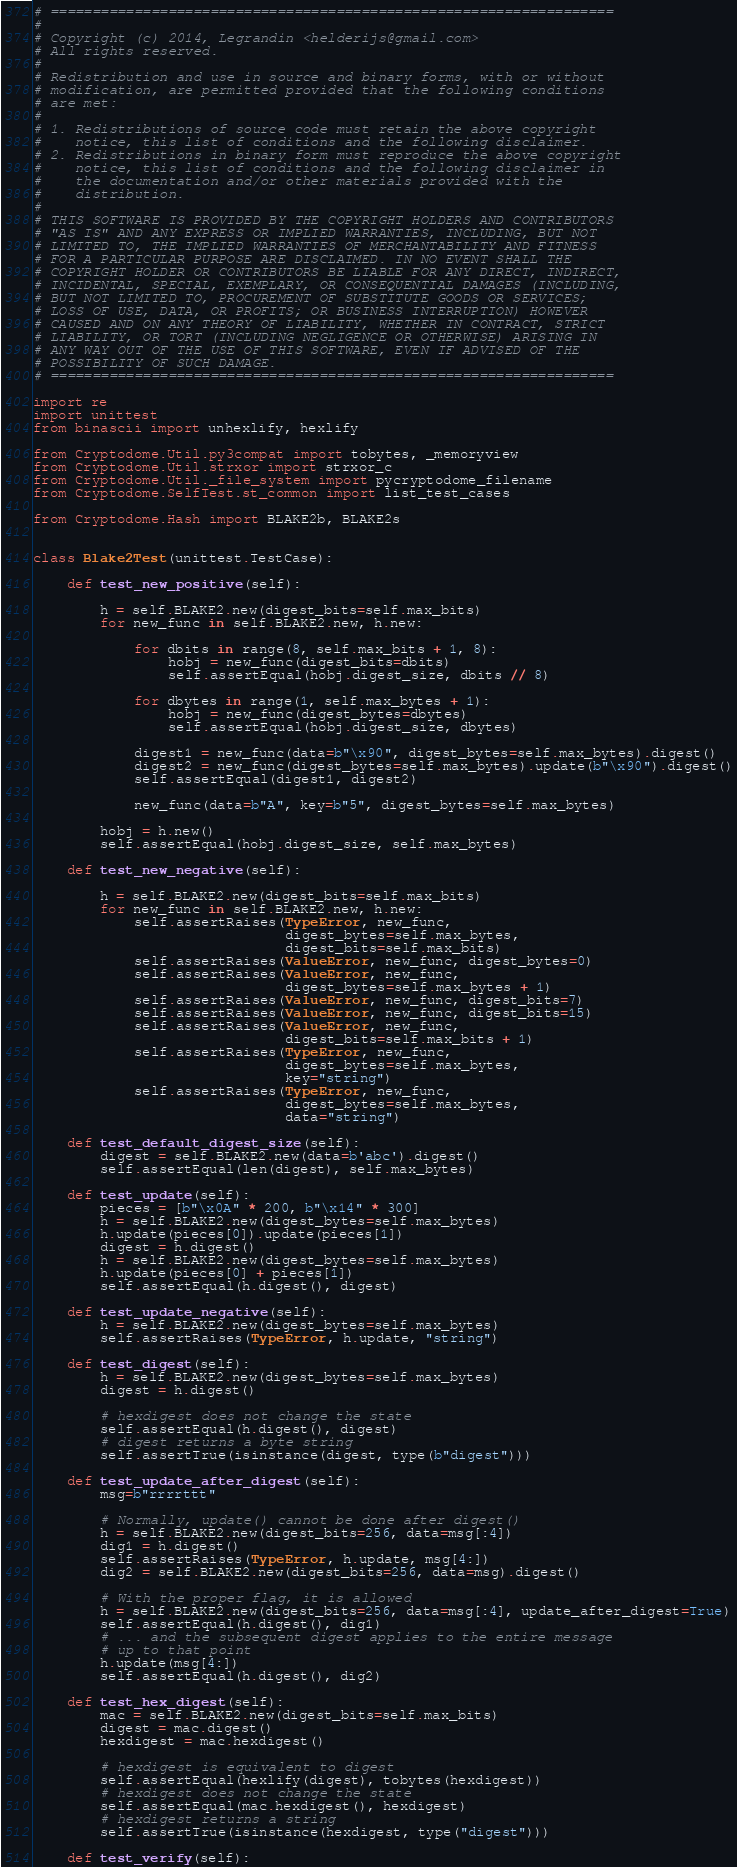Convert code to text. <code><loc_0><loc_0><loc_500><loc_500><_Python_># ===================================================================
#
# Copyright (c) 2014, Legrandin <helderijs@gmail.com>
# All rights reserved.
#
# Redistribution and use in source and binary forms, with or without
# modification, are permitted provided that the following conditions
# are met:
#
# 1. Redistributions of source code must retain the above copyright
#    notice, this list of conditions and the following disclaimer.
# 2. Redistributions in binary form must reproduce the above copyright
#    notice, this list of conditions and the following disclaimer in
#    the documentation and/or other materials provided with the
#    distribution.
#
# THIS SOFTWARE IS PROVIDED BY THE COPYRIGHT HOLDERS AND CONTRIBUTORS
# "AS IS" AND ANY EXPRESS OR IMPLIED WARRANTIES, INCLUDING, BUT NOT
# LIMITED TO, THE IMPLIED WARRANTIES OF MERCHANTABILITY AND FITNESS
# FOR A PARTICULAR PURPOSE ARE DISCLAIMED. IN NO EVENT SHALL THE
# COPYRIGHT HOLDER OR CONTRIBUTORS BE LIABLE FOR ANY DIRECT, INDIRECT,
# INCIDENTAL, SPECIAL, EXEMPLARY, OR CONSEQUENTIAL DAMAGES (INCLUDING,
# BUT NOT LIMITED TO, PROCUREMENT OF SUBSTITUTE GOODS OR SERVICES;
# LOSS OF USE, DATA, OR PROFITS; OR BUSINESS INTERRUPTION) HOWEVER
# CAUSED AND ON ANY THEORY OF LIABILITY, WHETHER IN CONTRACT, STRICT
# LIABILITY, OR TORT (INCLUDING NEGLIGENCE OR OTHERWISE) ARISING IN
# ANY WAY OUT OF THE USE OF THIS SOFTWARE, EVEN IF ADVISED OF THE
# POSSIBILITY OF SUCH DAMAGE.
# ===================================================================

import re
import unittest
from binascii import unhexlify, hexlify

from Cryptodome.Util.py3compat import tobytes, _memoryview
from Cryptodome.Util.strxor import strxor_c
from Cryptodome.Util._file_system import pycryptodome_filename
from Cryptodome.SelfTest.st_common import list_test_cases

from Cryptodome.Hash import BLAKE2b, BLAKE2s


class Blake2Test(unittest.TestCase):

    def test_new_positive(self):

        h = self.BLAKE2.new(digest_bits=self.max_bits)
        for new_func in self.BLAKE2.new, h.new:

            for dbits in range(8, self.max_bits + 1, 8):
                hobj = new_func(digest_bits=dbits)
                self.assertEqual(hobj.digest_size, dbits // 8)

            for dbytes in range(1, self.max_bytes + 1):
                hobj = new_func(digest_bytes=dbytes)
                self.assertEqual(hobj.digest_size, dbytes)

            digest1 = new_func(data=b"\x90", digest_bytes=self.max_bytes).digest()
            digest2 = new_func(digest_bytes=self.max_bytes).update(b"\x90").digest()
            self.assertEqual(digest1, digest2)

            new_func(data=b"A", key=b"5", digest_bytes=self.max_bytes)

        hobj = h.new()
        self.assertEqual(hobj.digest_size, self.max_bytes)

    def test_new_negative(self):

        h = self.BLAKE2.new(digest_bits=self.max_bits)
        for new_func in self.BLAKE2.new, h.new:
            self.assertRaises(TypeError, new_func,
                              digest_bytes=self.max_bytes,
                              digest_bits=self.max_bits)
            self.assertRaises(ValueError, new_func, digest_bytes=0)
            self.assertRaises(ValueError, new_func,
                              digest_bytes=self.max_bytes + 1)
            self.assertRaises(ValueError, new_func, digest_bits=7)
            self.assertRaises(ValueError, new_func, digest_bits=15)
            self.assertRaises(ValueError, new_func,
                              digest_bits=self.max_bits + 1)
            self.assertRaises(TypeError, new_func,
                              digest_bytes=self.max_bytes,
                              key="string")
            self.assertRaises(TypeError, new_func,
                              digest_bytes=self.max_bytes,
                              data="string")

    def test_default_digest_size(self):
        digest = self.BLAKE2.new(data=b'abc').digest()
        self.assertEqual(len(digest), self.max_bytes)

    def test_update(self):
        pieces = [b"\x0A" * 200, b"\x14" * 300]
        h = self.BLAKE2.new(digest_bytes=self.max_bytes)
        h.update(pieces[0]).update(pieces[1])
        digest = h.digest()
        h = self.BLAKE2.new(digest_bytes=self.max_bytes)
        h.update(pieces[0] + pieces[1])
        self.assertEqual(h.digest(), digest)

    def test_update_negative(self):
        h = self.BLAKE2.new(digest_bytes=self.max_bytes)
        self.assertRaises(TypeError, h.update, "string")

    def test_digest(self):
        h = self.BLAKE2.new(digest_bytes=self.max_bytes)
        digest = h.digest()

        # hexdigest does not change the state
        self.assertEqual(h.digest(), digest)
        # digest returns a byte string
        self.assertTrue(isinstance(digest, type(b"digest")))

    def test_update_after_digest(self):
        msg=b"rrrrttt"

        # Normally, update() cannot be done after digest()
        h = self.BLAKE2.new(digest_bits=256, data=msg[:4])
        dig1 = h.digest()
        self.assertRaises(TypeError, h.update, msg[4:])
        dig2 = self.BLAKE2.new(digest_bits=256, data=msg).digest()

        # With the proper flag, it is allowed
        h = self.BLAKE2.new(digest_bits=256, data=msg[:4], update_after_digest=True)
        self.assertEqual(h.digest(), dig1)
        # ... and the subsequent digest applies to the entire message
        # up to that point
        h.update(msg[4:])
        self.assertEqual(h.digest(), dig2)

    def test_hex_digest(self):
        mac = self.BLAKE2.new(digest_bits=self.max_bits)
        digest = mac.digest()
        hexdigest = mac.hexdigest()

        # hexdigest is equivalent to digest
        self.assertEqual(hexlify(digest), tobytes(hexdigest))
        # hexdigest does not change the state
        self.assertEqual(mac.hexdigest(), hexdigest)
        # hexdigest returns a string
        self.assertTrue(isinstance(hexdigest, type("digest")))

    def test_verify(self):</code> 